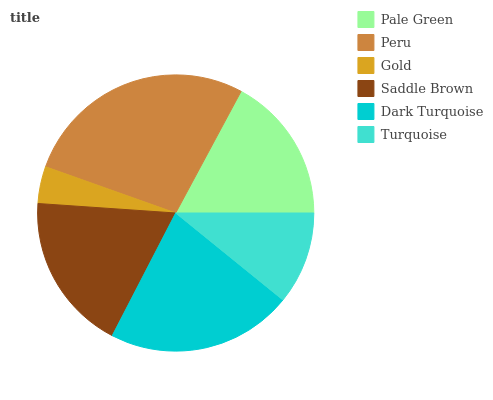Is Gold the minimum?
Answer yes or no. Yes. Is Peru the maximum?
Answer yes or no. Yes. Is Peru the minimum?
Answer yes or no. No. Is Gold the maximum?
Answer yes or no. No. Is Peru greater than Gold?
Answer yes or no. Yes. Is Gold less than Peru?
Answer yes or no. Yes. Is Gold greater than Peru?
Answer yes or no. No. Is Peru less than Gold?
Answer yes or no. No. Is Saddle Brown the high median?
Answer yes or no. Yes. Is Pale Green the low median?
Answer yes or no. Yes. Is Turquoise the high median?
Answer yes or no. No. Is Dark Turquoise the low median?
Answer yes or no. No. 